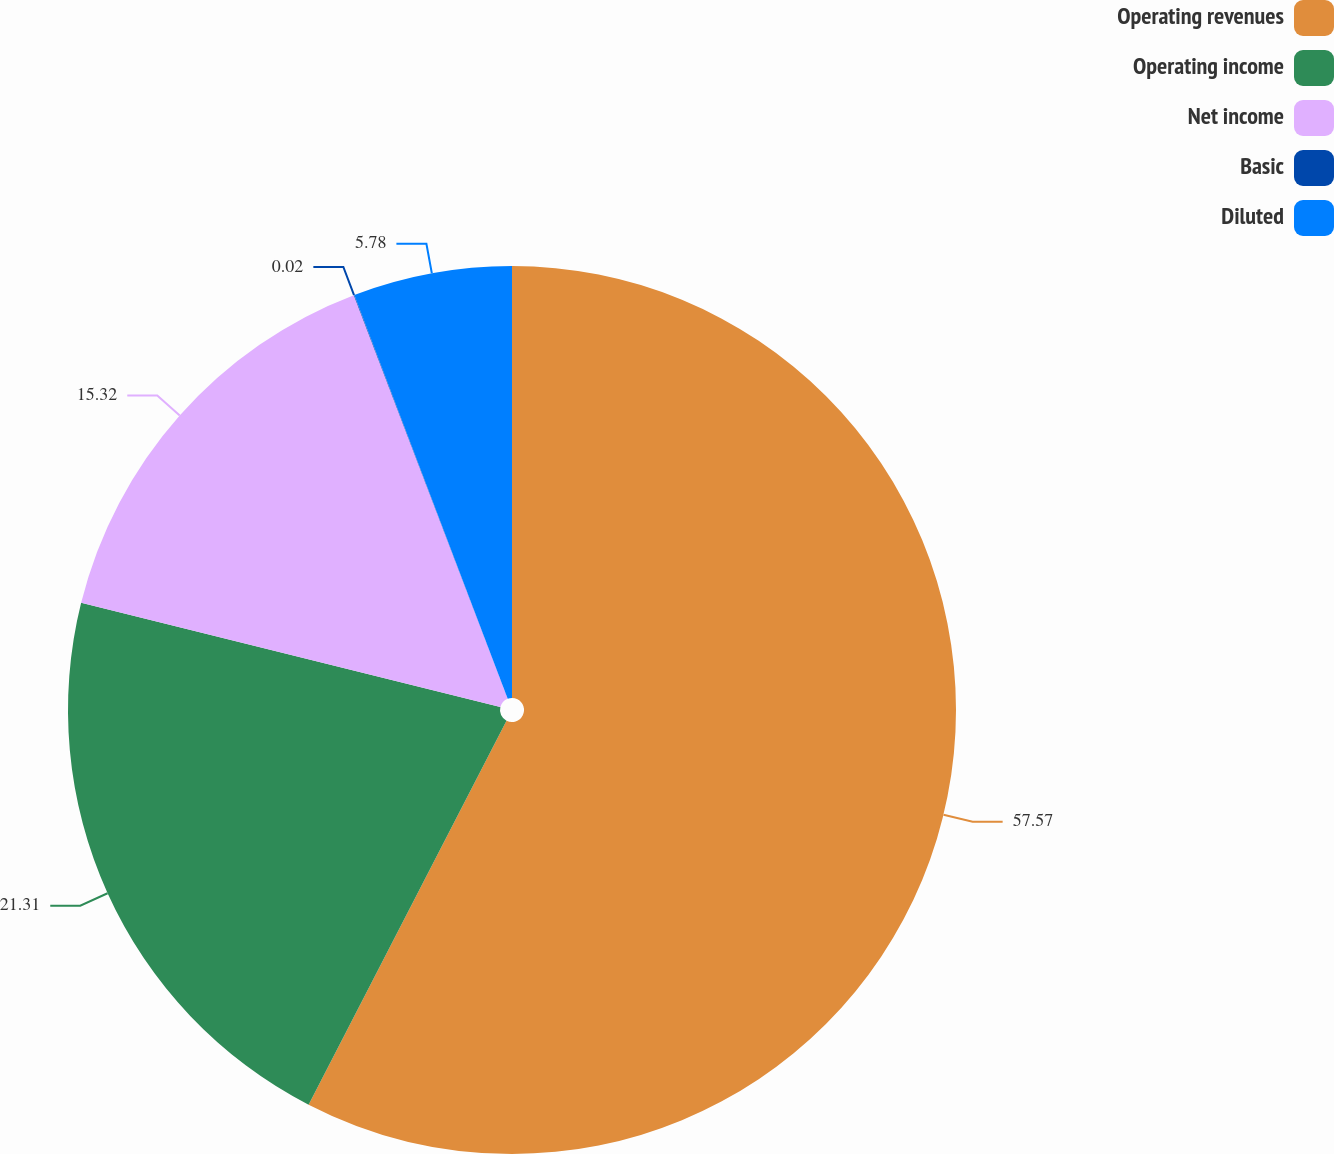Convert chart. <chart><loc_0><loc_0><loc_500><loc_500><pie_chart><fcel>Operating revenues<fcel>Operating income<fcel>Net income<fcel>Basic<fcel>Diluted<nl><fcel>57.58%<fcel>21.31%<fcel>15.32%<fcel>0.02%<fcel>5.78%<nl></chart> 